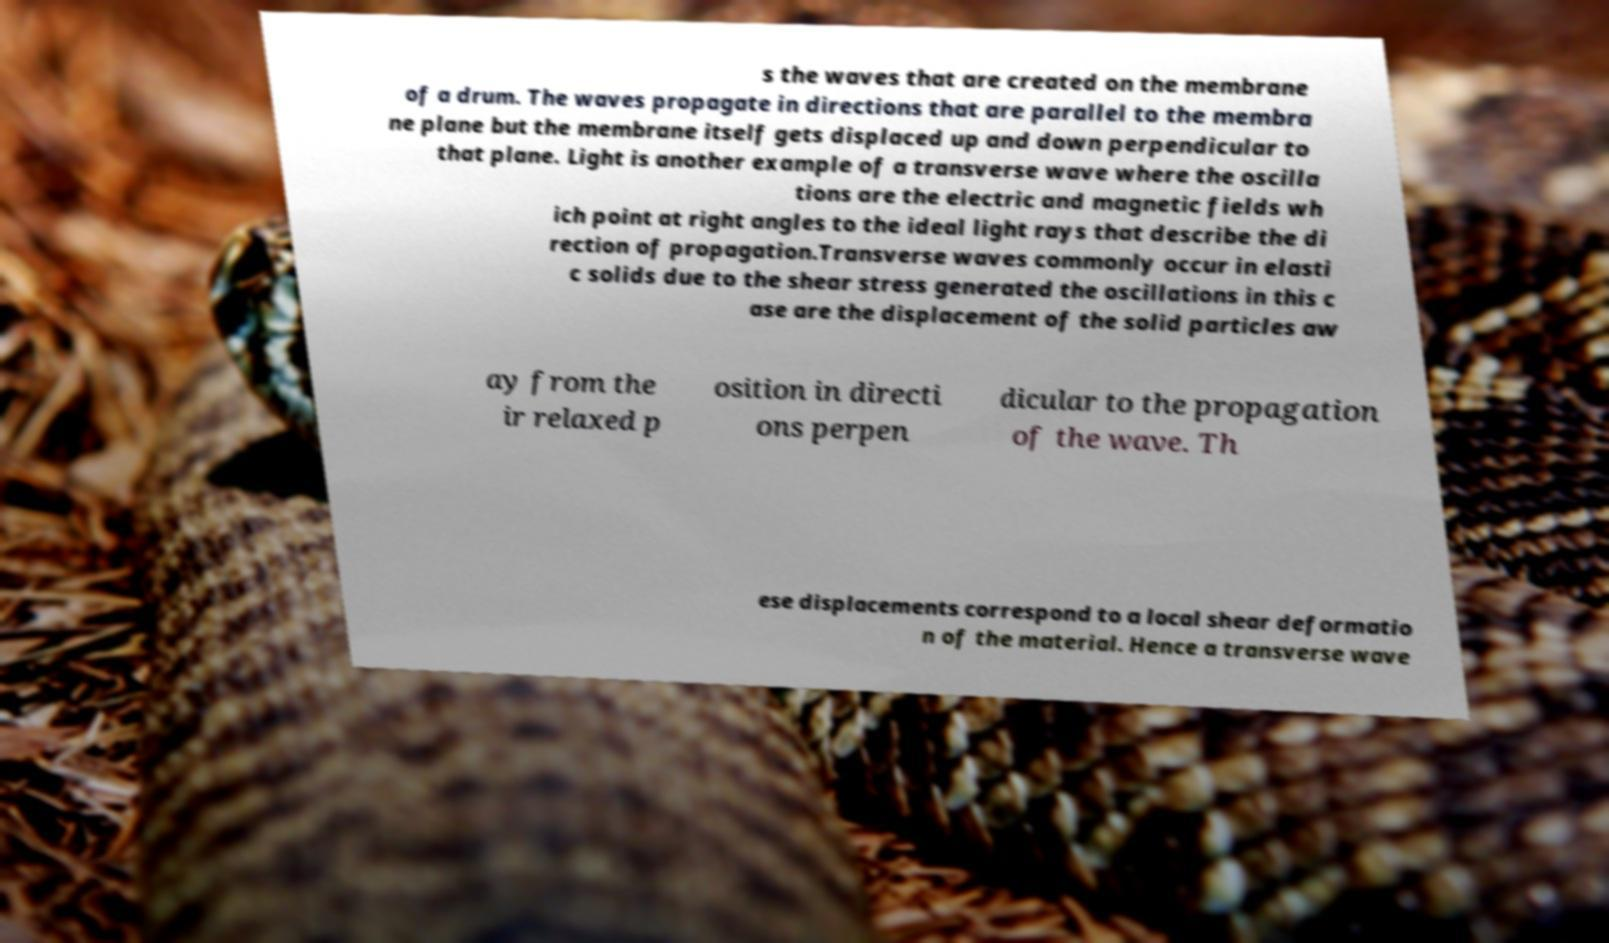Please read and relay the text visible in this image. What does it say? s the waves that are created on the membrane of a drum. The waves propagate in directions that are parallel to the membra ne plane but the membrane itself gets displaced up and down perpendicular to that plane. Light is another example of a transverse wave where the oscilla tions are the electric and magnetic fields wh ich point at right angles to the ideal light rays that describe the di rection of propagation.Transverse waves commonly occur in elasti c solids due to the shear stress generated the oscillations in this c ase are the displacement of the solid particles aw ay from the ir relaxed p osition in directi ons perpen dicular to the propagation of the wave. Th ese displacements correspond to a local shear deformatio n of the material. Hence a transverse wave 